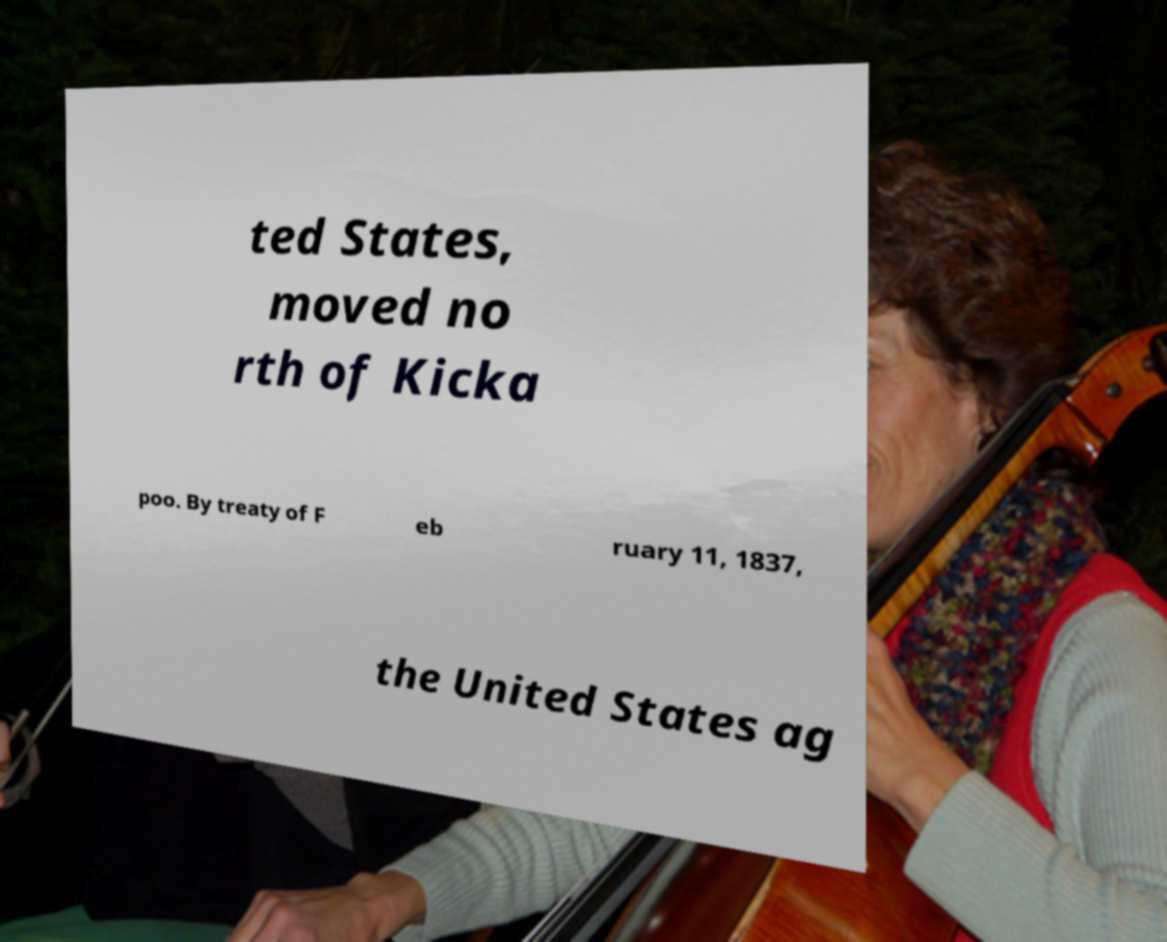I need the written content from this picture converted into text. Can you do that? ted States, moved no rth of Kicka poo. By treaty of F eb ruary 11, 1837, the United States ag 